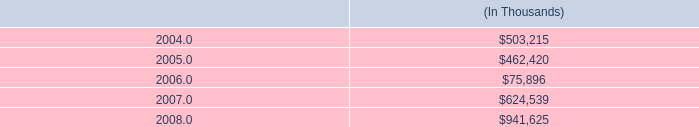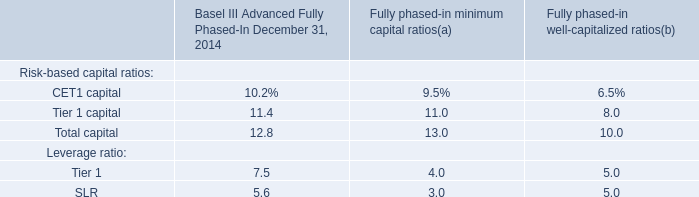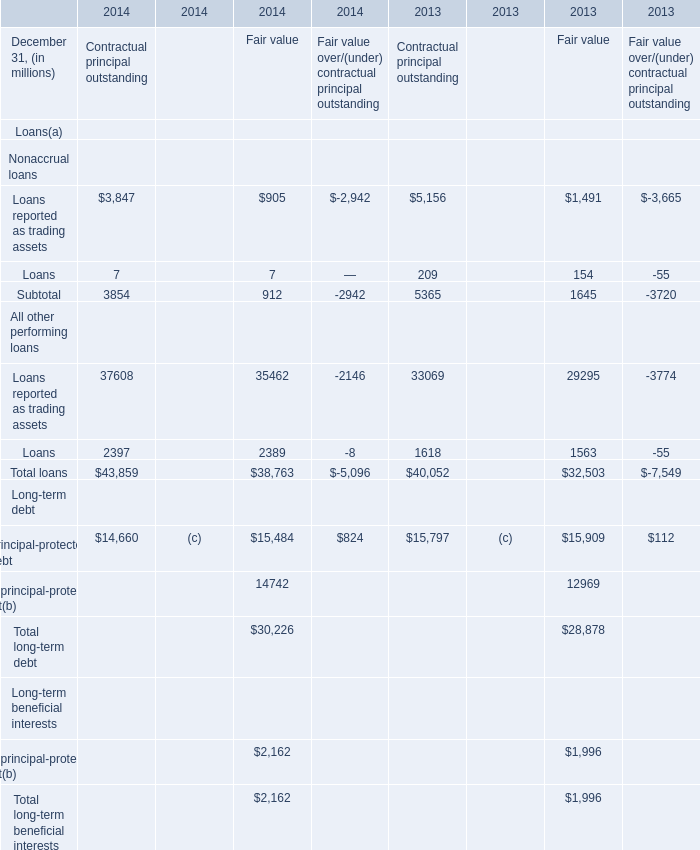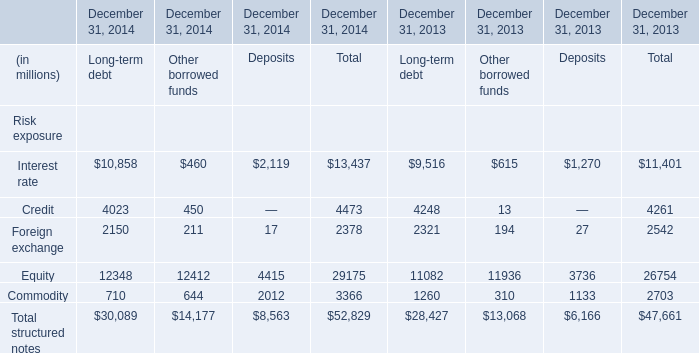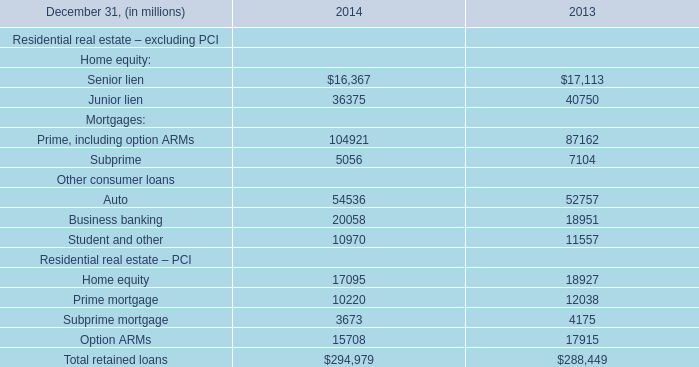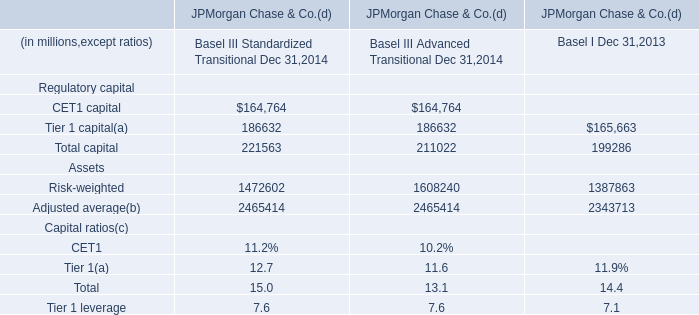what's the total amount of Junior lien of 2013, and Equity of December 31, 2014 Other borrowed funds ? 
Computations: (40750.0 + 12412.0)
Answer: 53162.0. 